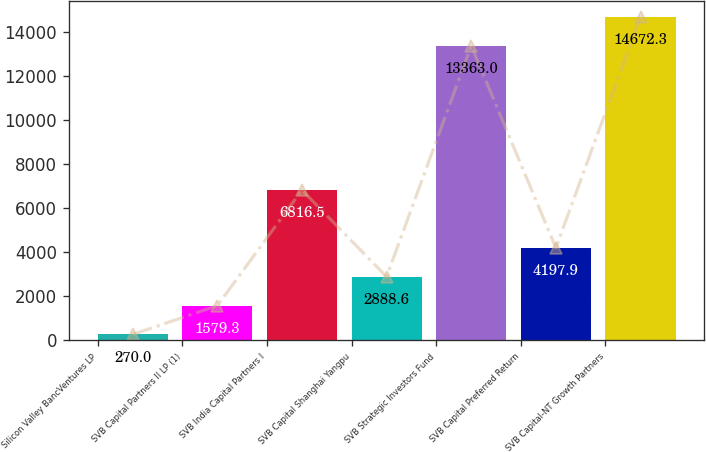Convert chart. <chart><loc_0><loc_0><loc_500><loc_500><bar_chart><fcel>Silicon Valley BancVentures LP<fcel>SVB Capital Partners II LP (1)<fcel>SVB India Capital Partners I<fcel>SVB Capital Shanghai Yangpu<fcel>SVB Strategic Investors Fund<fcel>SVB Capital Preferred Return<fcel>SVB Capital-NT Growth Partners<nl><fcel>270<fcel>1579.3<fcel>6816.5<fcel>2888.6<fcel>13363<fcel>4197.9<fcel>14672.3<nl></chart> 